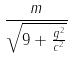Convert formula to latex. <formula><loc_0><loc_0><loc_500><loc_500>\frac { m } { \sqrt { 9 + \frac { g ^ { 2 } } { c ^ { 2 } } } }</formula> 